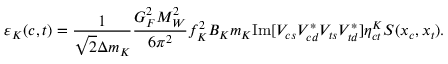Convert formula to latex. <formula><loc_0><loc_0><loc_500><loc_500>\varepsilon _ { K } ( c , t ) = \frac { 1 } { \sqrt { 2 } \Delta m _ { K } } \frac { G _ { F } ^ { 2 } M _ { W } ^ { 2 } } { 6 \pi ^ { 2 } } f _ { K } ^ { 2 } B _ { K } m _ { K } I m [ V _ { c s } V _ { c d } ^ { * } V _ { t s } V _ { t d } ^ { * } ] \eta _ { c t } ^ { K } S ( x _ { c } , x _ { t } ) .</formula> 